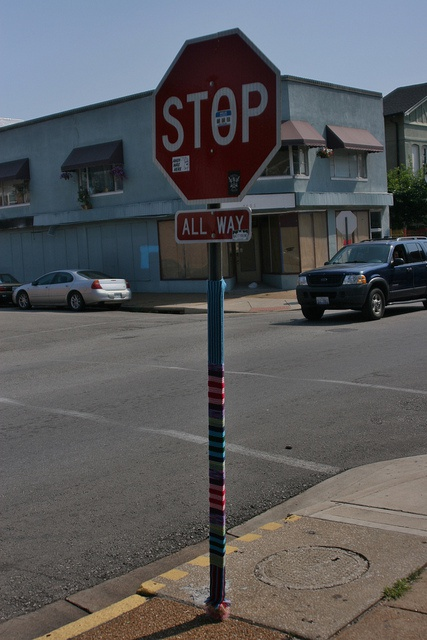Describe the objects in this image and their specific colors. I can see stop sign in darkgray, black, gray, and darkblue tones, car in darkgray, black, gray, and darkblue tones, car in darkgray, black, and gray tones, stop sign in darkgray, gray, black, and purple tones, and car in darkgray, black, gray, darkblue, and blue tones in this image. 